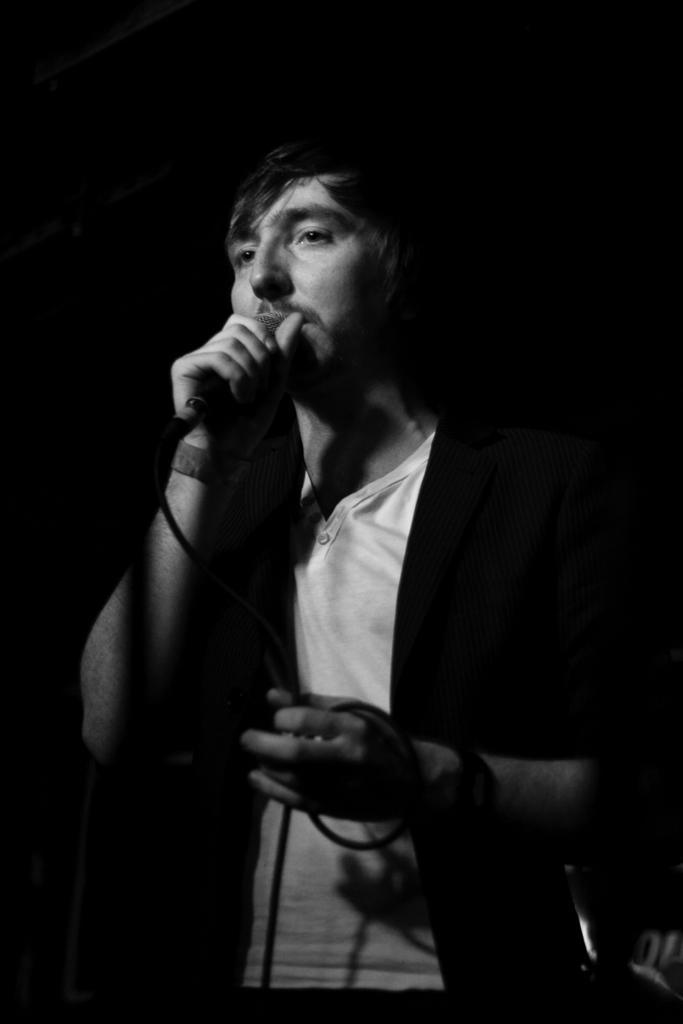How would you summarize this image in a sentence or two? In this image i can see man singing holding a microphone. 